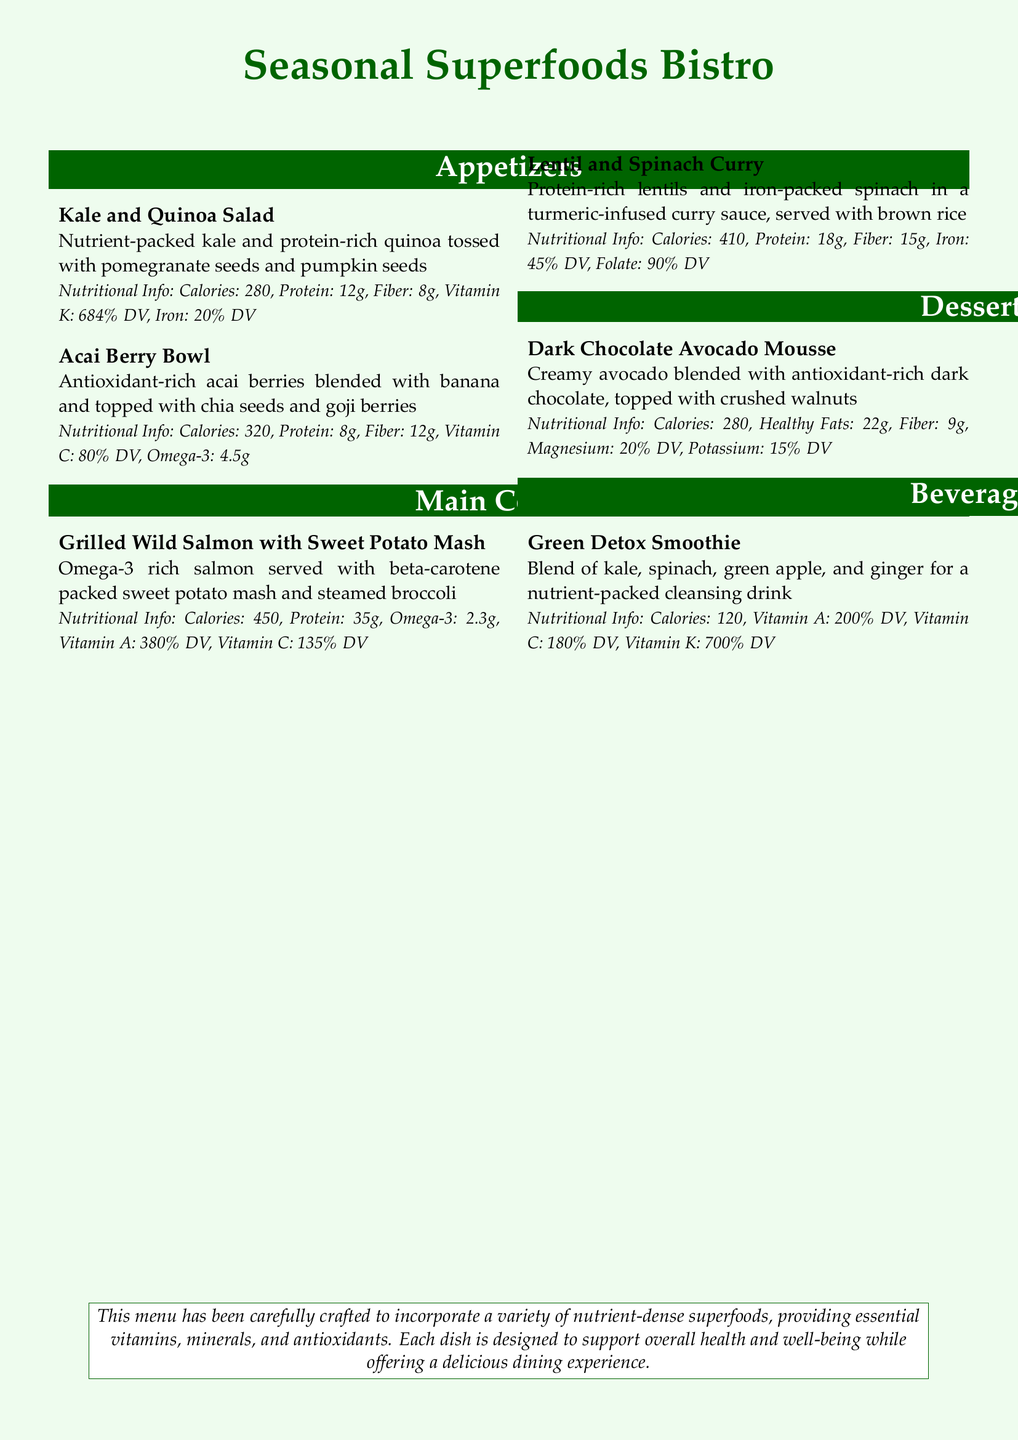What is the first appetizer listed? The first appetizer listed is the Kale and Quinoa Salad.
Answer: Kale and Quinoa Salad How many grams of protein are in the Grilled Wild Salmon with Sweet Potato Mash? The dish contains 35 grams of protein as stated in its nutritional info.
Answer: 35g What is the calorie count of the Acai Berry Bowl? The calorie count for the Acai Berry Bowl is specified as 320 calories.
Answer: 320 Which dessert contains healthy fats? The Dark Chocolate Avocado Mousse is noted to have healthy fats in its nutritional information.
Answer: Dark Chocolate Avocado Mousse What vitamin is highest in the Green Detox Smoothie? The document states that the Green Detox Smoothie has a high Vitamin K content.
Answer: Vitamin K How much iron does the Lentil and Spinach Curry provide? The dish provides 45% of the daily value of iron according to its nutritional information.
Answer: 45% DV What type of sauce is the Lentil and Spinach Curry served in? The dish is served in a turmeric-infused curry sauce, as mentioned in the description.
Answer: turmeric-infused curry sauce What is the total calorie count of all appetizers? The Kale and Quinoa Salad has 280 calories and the Acai Berry Bowl has 320 calories, totaling 600 calories.
Answer: 600 Which beverage is designed for detox cleansing? The Green Detox Smoothie is indicated as a nutrient-packed cleansing drink.
Answer: Green Detox Smoothie 